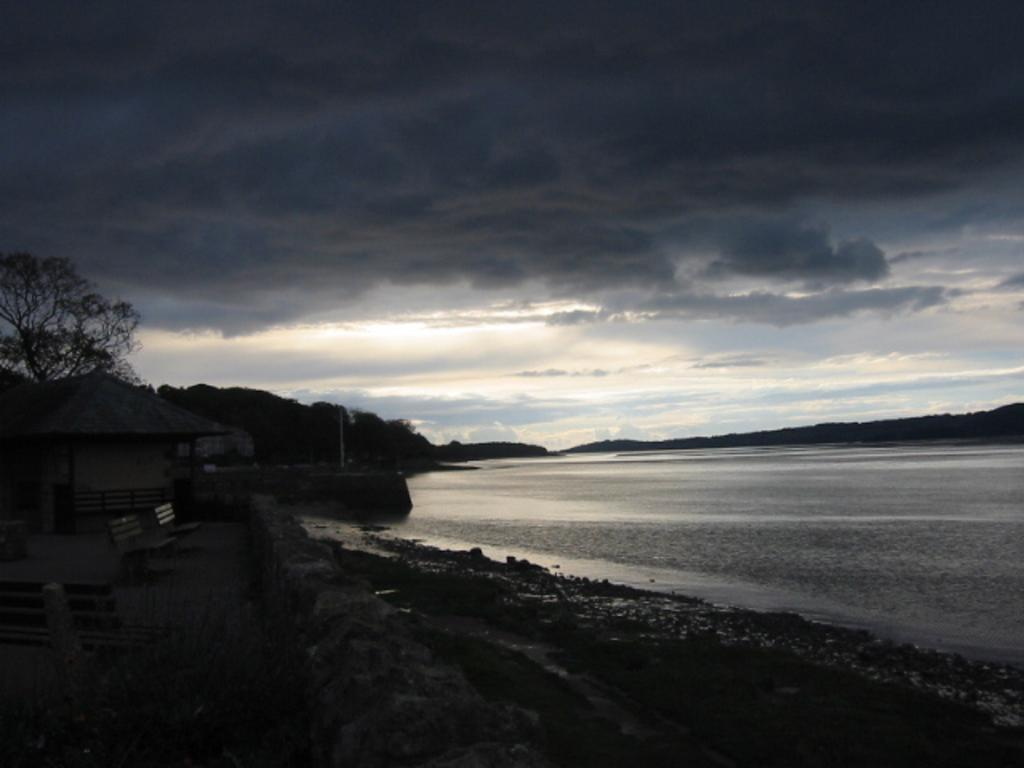What is the main element present in the image? There is water in the image. What type of seating can be seen in the image? There are benches in the image. What type of vegetation is present in the image? There are trees in the image. How would you describe the sky in the image? The sky is blue and cloudy in the image. What type of test is being conducted on the paper in the image? There is no paper or test present in the image; it features water, benches, trees, and a blue and cloudy sky. 